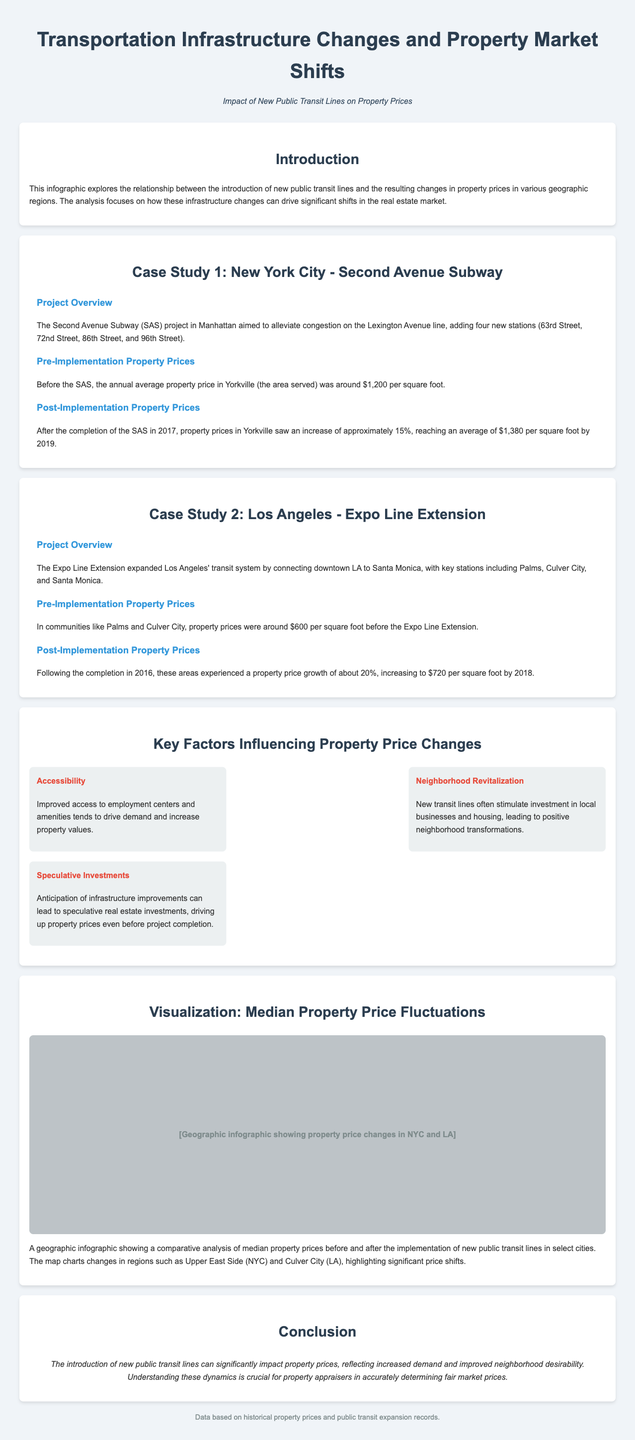what is the name of the subway project in Manhattan? The document refers to the subway project as the "Second Avenue Subway (SAS)."
Answer: Second Avenue Subway how many new stations were added in the Second Avenue Subway project? The document states that the SAS project added four new stations.
Answer: four what was the average property price in Yorkville before the SAS implementation? The pre-implementation average property price in Yorkville was around $1,200 per square foot.
Answer: $1,200 per square foot what was the percentage increase in property prices in Yorkville after the SAS completion? The document mentions a 15% increase in property prices in Yorkville following the SAS completion.
Answer: 15% which city had a property price of $600 per square foot before the Expo Line Extension? The document indicates Los Angeles had a property price of $600 per square foot before the Expo Line Extension.
Answer: Los Angeles how much did property prices increase in Culver City after the Expo Line Extension? The document notes a property price growth of about 20% in Culver City after the Expo Line Extension.
Answer: 20% what is one key factor influencing property price changes mentioned in the document? The document lists “Accessibility” as one of the key factors influencing property price changes.
Answer: Accessibility what type of visual data is included in the infographic? The document includes a geographic infographic showing median property price fluctuations.
Answer: geographic infographic how is the conclusion summarized regarding new public transit lines? The conclusion states that new public transit lines significantly impact property prices, reflecting increased demand.
Answer: significant impact 